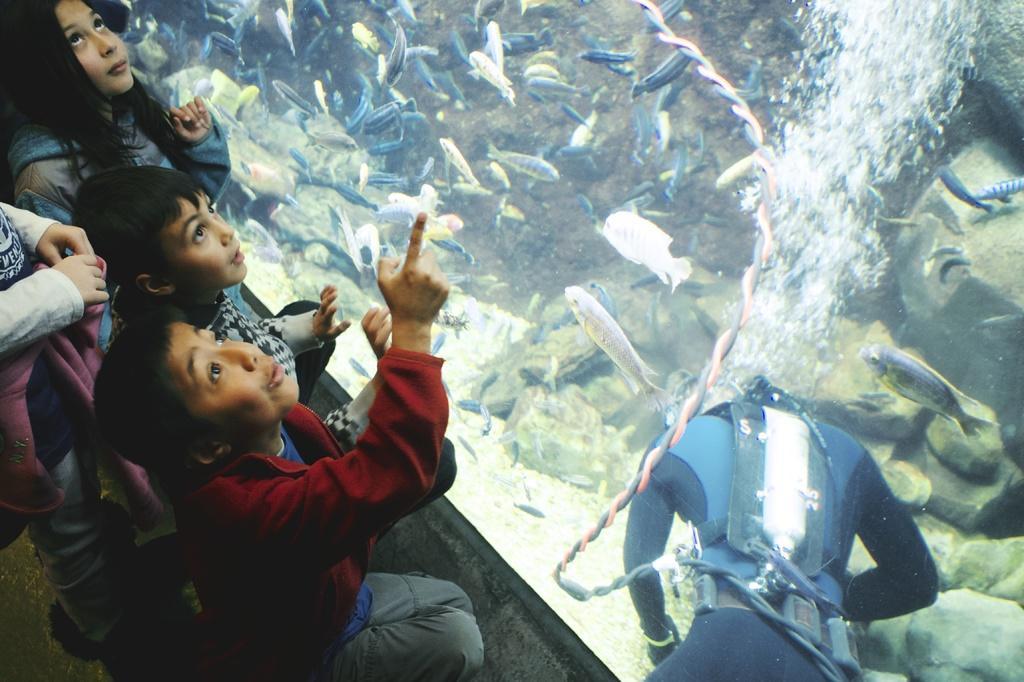Please provide a concise description of this image. In this aquarium we can see water, fishes and a person with wire. Beside this aquarium we can see children. 